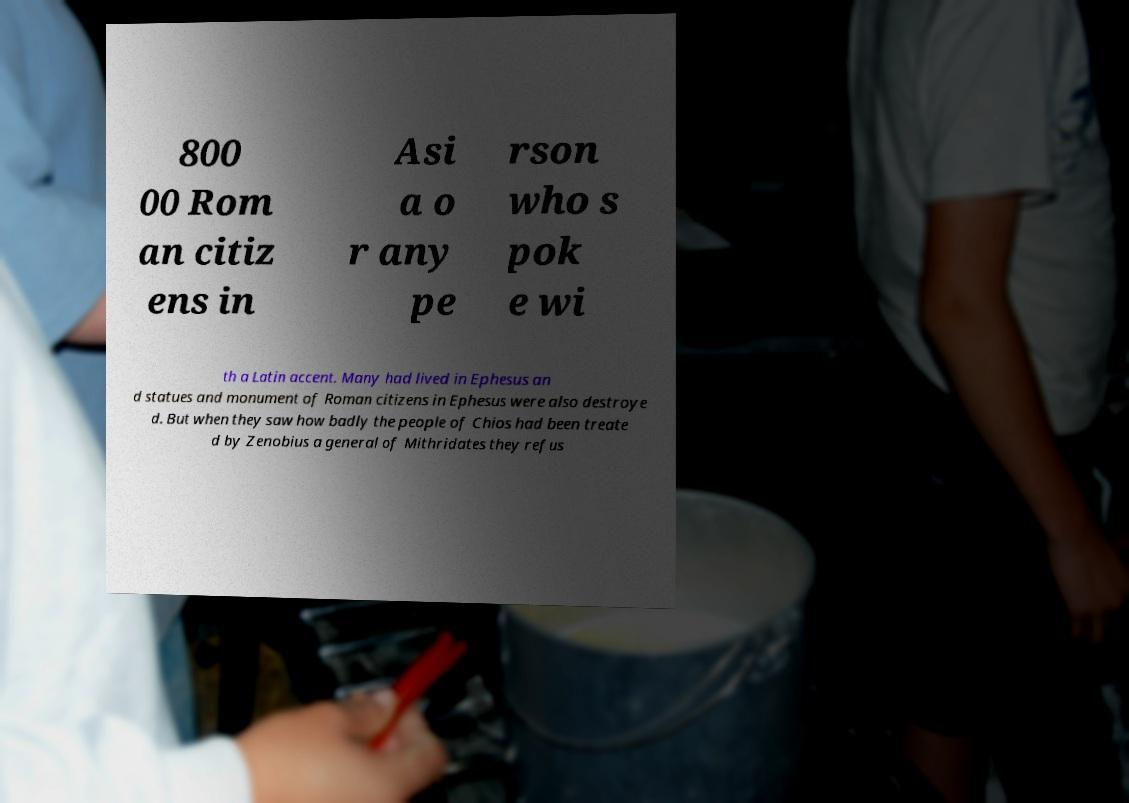Please identify and transcribe the text found in this image. 800 00 Rom an citiz ens in Asi a o r any pe rson who s pok e wi th a Latin accent. Many had lived in Ephesus an d statues and monument of Roman citizens in Ephesus were also destroye d. But when they saw how badly the people of Chios had been treate d by Zenobius a general of Mithridates they refus 